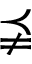Convert formula to latex. <formula><loc_0><loc_0><loc_500><loc_500>\precneqq</formula> 